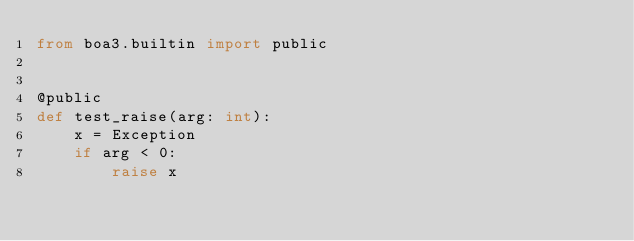<code> <loc_0><loc_0><loc_500><loc_500><_Python_>from boa3.builtin import public


@public
def test_raise(arg: int):
    x = Exception
    if arg < 0:
        raise x
</code> 